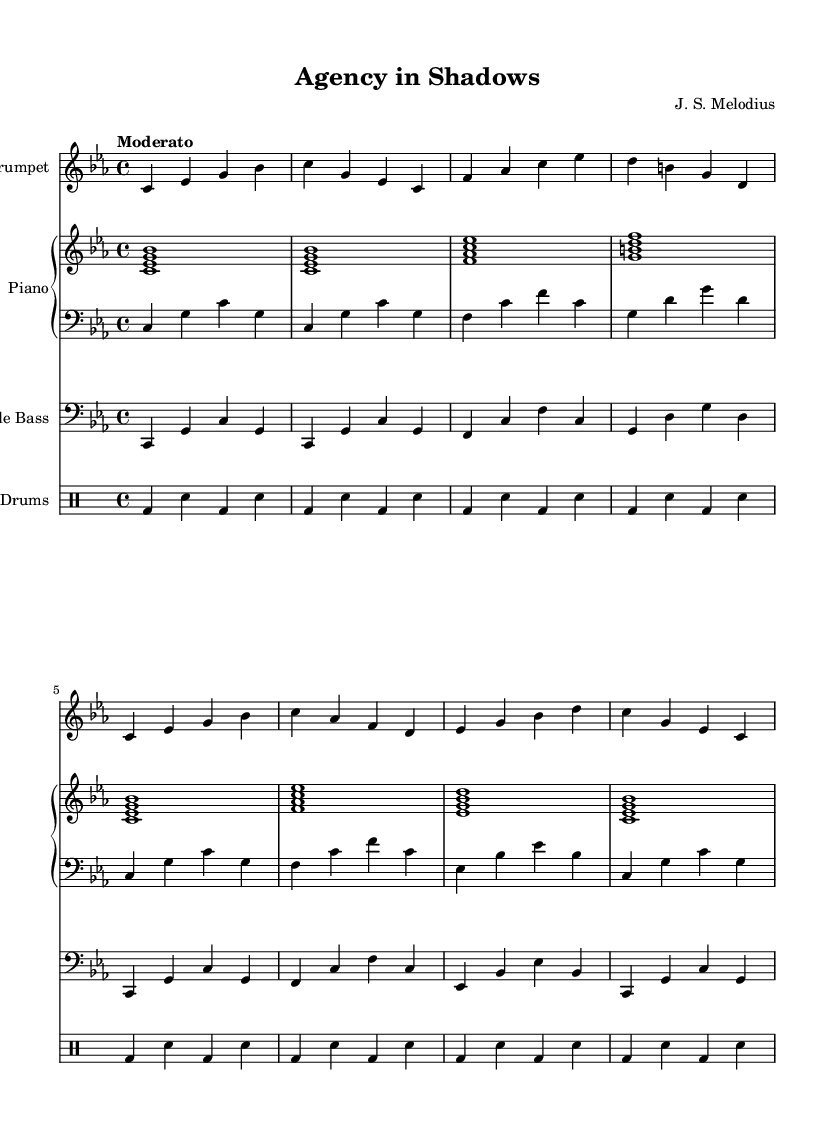What is the key signature of this music? The key signature is C minor, which contains three flats (B♭, E♭, and A♭). This is indicated by the flats at the beginning of the staff.
Answer: C minor What is the time signature of this composition? The time signature is 4/4, which means there are four beats in each measure and the quarter note gets one beat. This is shown at the beginning of the score.
Answer: 4/4 What is the tempo marking for this piece? The tempo marking is "Moderato," which suggests a moderate pace for the performance. It's written above the staff at the beginning of the score.
Answer: Moderato How many measures does the trumpet part have? The trumpet part has eight measures, as indicated by the groups of notes separated by vertical lines which represent the boundaries of each measure.
Answer: Eight Which instruments are included in this score? The score features a trumpet, piano (with right and left hand parts), double bass, and drums. This can be determined by the instrument names at the beginning of each staff.
Answer: Trumpet, piano, double bass, drums What type of musical composition is this? This composition falls under the category of soundtracks, particularly sophisticated jazz, as indicated by the context and the style of the music written in the score.
Answer: Soundtrack What is the rhythmic pattern played by the drums? The drum part consists of a repeated pattern of bass drum and snare hits, creating a steady rhythmic foundation across eight measures, specified by the drum notation that indicates the specific hits.
Answer: Bass and snare 